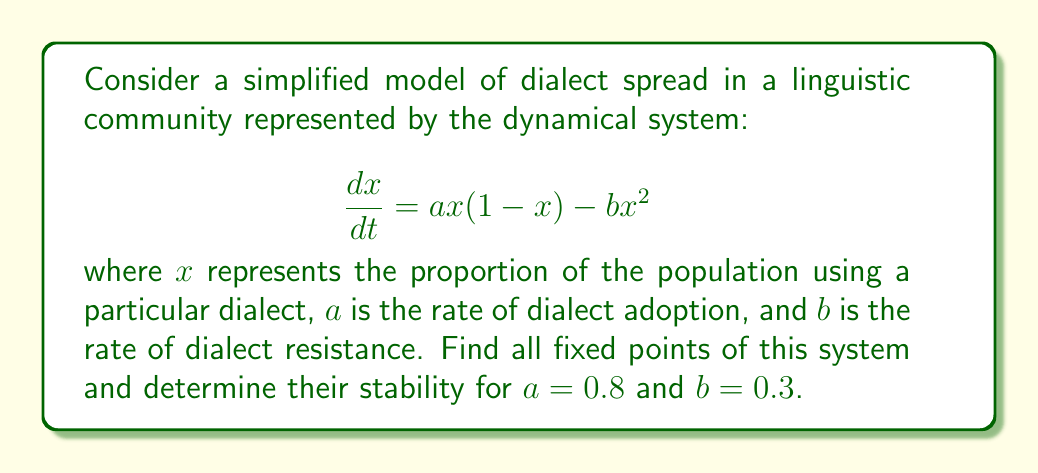Teach me how to tackle this problem. 1) To find the fixed points, we set $\frac{dx}{dt} = 0$:

   $$ax(1-x) - bx^2 = 0$$

2) Factor out $x$:

   $$x(a(1-x) - bx) = 0$$

3) Solve for $x$:
   
   Case 1: $x = 0$ (trivial fixed point)
   
   Case 2: $a(1-x) - bx = 0$
           $a - ax - bx = 0$
           $a - x(a+b) = 0$
           $x = \frac{a}{a+b}$

4) Substitute the given values $a=0.8$ and $b=0.3$:

   $$x = \frac{0.8}{0.8+0.3} = \frac{0.8}{1.1} \approx 0.7273$$

5) To determine stability, we evaluate the derivative of the right-hand side at each fixed point:

   $$\frac{d}{dx}(ax(1-x) - bx^2) = a(1-2x) - 2bx$$

6) At $x=0$:
   
   $$a(1-2(0)) - 2b(0) = a = 0.8 > 0$$
   
   This is positive, so $x=0$ is an unstable fixed point.

7) At $x \approx 0.7273$:
   
   $$0.8(1-2(0.7273)) - 2(0.3)(0.7273) \approx -0.8 < 0$$
   
   This is negative, so $x \approx 0.7273$ is a stable fixed point.
Answer: Fixed points: $x_1=0$ (unstable), $x_2\approx0.7273$ (stable) 